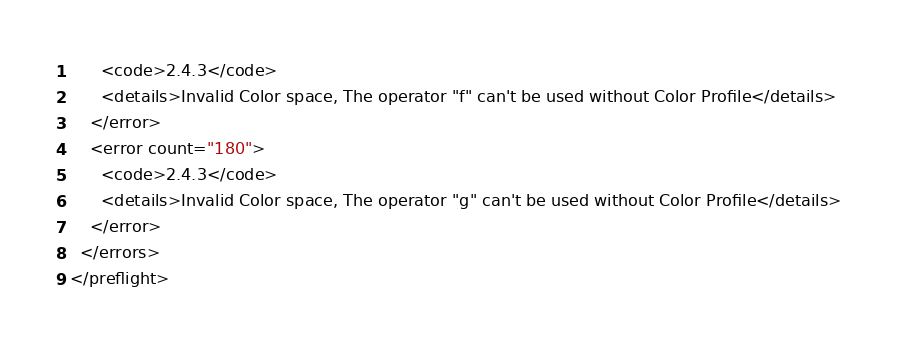Convert code to text. <code><loc_0><loc_0><loc_500><loc_500><_XML_>      <code>2.4.3</code>
      <details>Invalid Color space, The operator "f" can't be used without Color Profile</details>
    </error>
    <error count="180">
      <code>2.4.3</code>
      <details>Invalid Color space, The operator "g" can't be used without Color Profile</details>
    </error>
  </errors>
</preflight>
</code> 